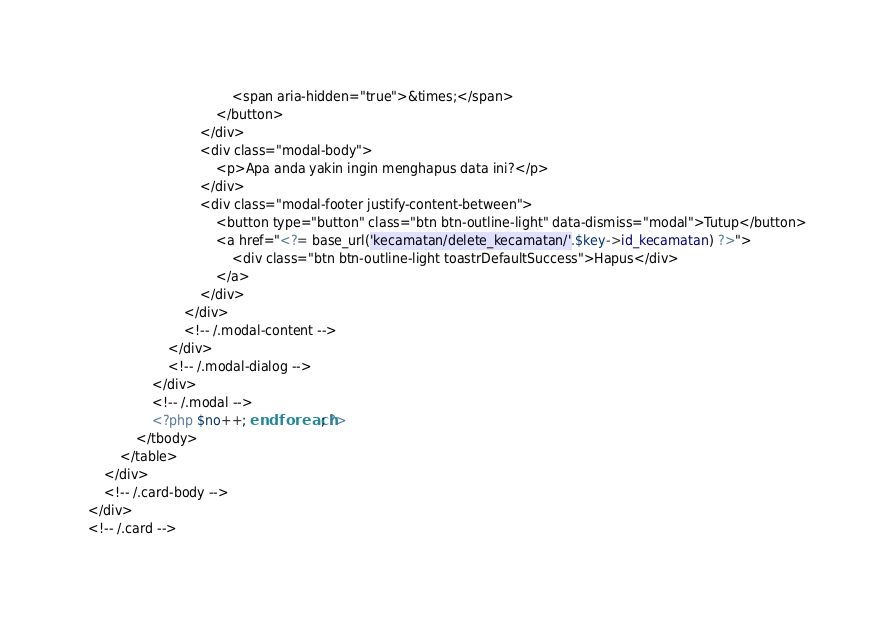<code> <loc_0><loc_0><loc_500><loc_500><_PHP_>									<span aria-hidden="true">&times;</span>
								</button>
							</div>
							<div class="modal-body">
								<p>Apa anda yakin ingin menghapus data ini?</p>
							</div>
							<div class="modal-footer justify-content-between">
								<button type="button" class="btn btn-outline-light" data-dismiss="modal">Tutup</button>
								<a href="<?= base_url('kecamatan/delete_kecamatan/'.$key->id_kecamatan) ?>">
									<div class="btn btn-outline-light toastrDefaultSuccess">Hapus</div>
								</a>
							</div>
						</div>
						<!-- /.modal-content -->
					</div>
					<!-- /.modal-dialog -->
				</div>
				<!-- /.modal -->
				<?php $no++; endforeach; ?>
			</tbody>
		</table>
	</div>
	<!-- /.card-body -->
</div>
<!-- /.card -->
</code> 